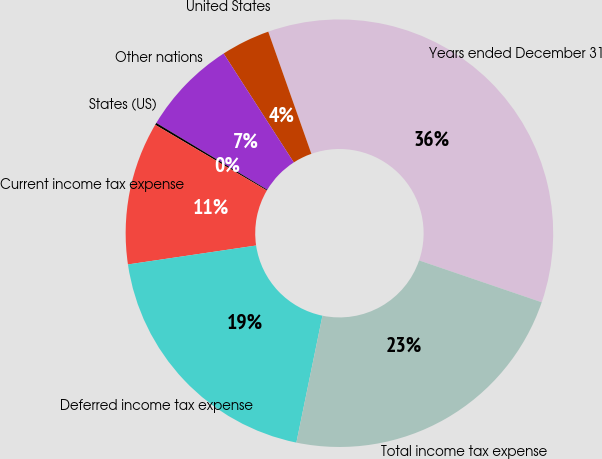Convert chart. <chart><loc_0><loc_0><loc_500><loc_500><pie_chart><fcel>Years ended December 31<fcel>United States<fcel>Other nations<fcel>States (US)<fcel>Current income tax expense<fcel>Deferred income tax expense<fcel>Total income tax expense<nl><fcel>35.64%<fcel>3.71%<fcel>7.26%<fcel>0.16%<fcel>10.8%<fcel>19.44%<fcel>22.99%<nl></chart> 